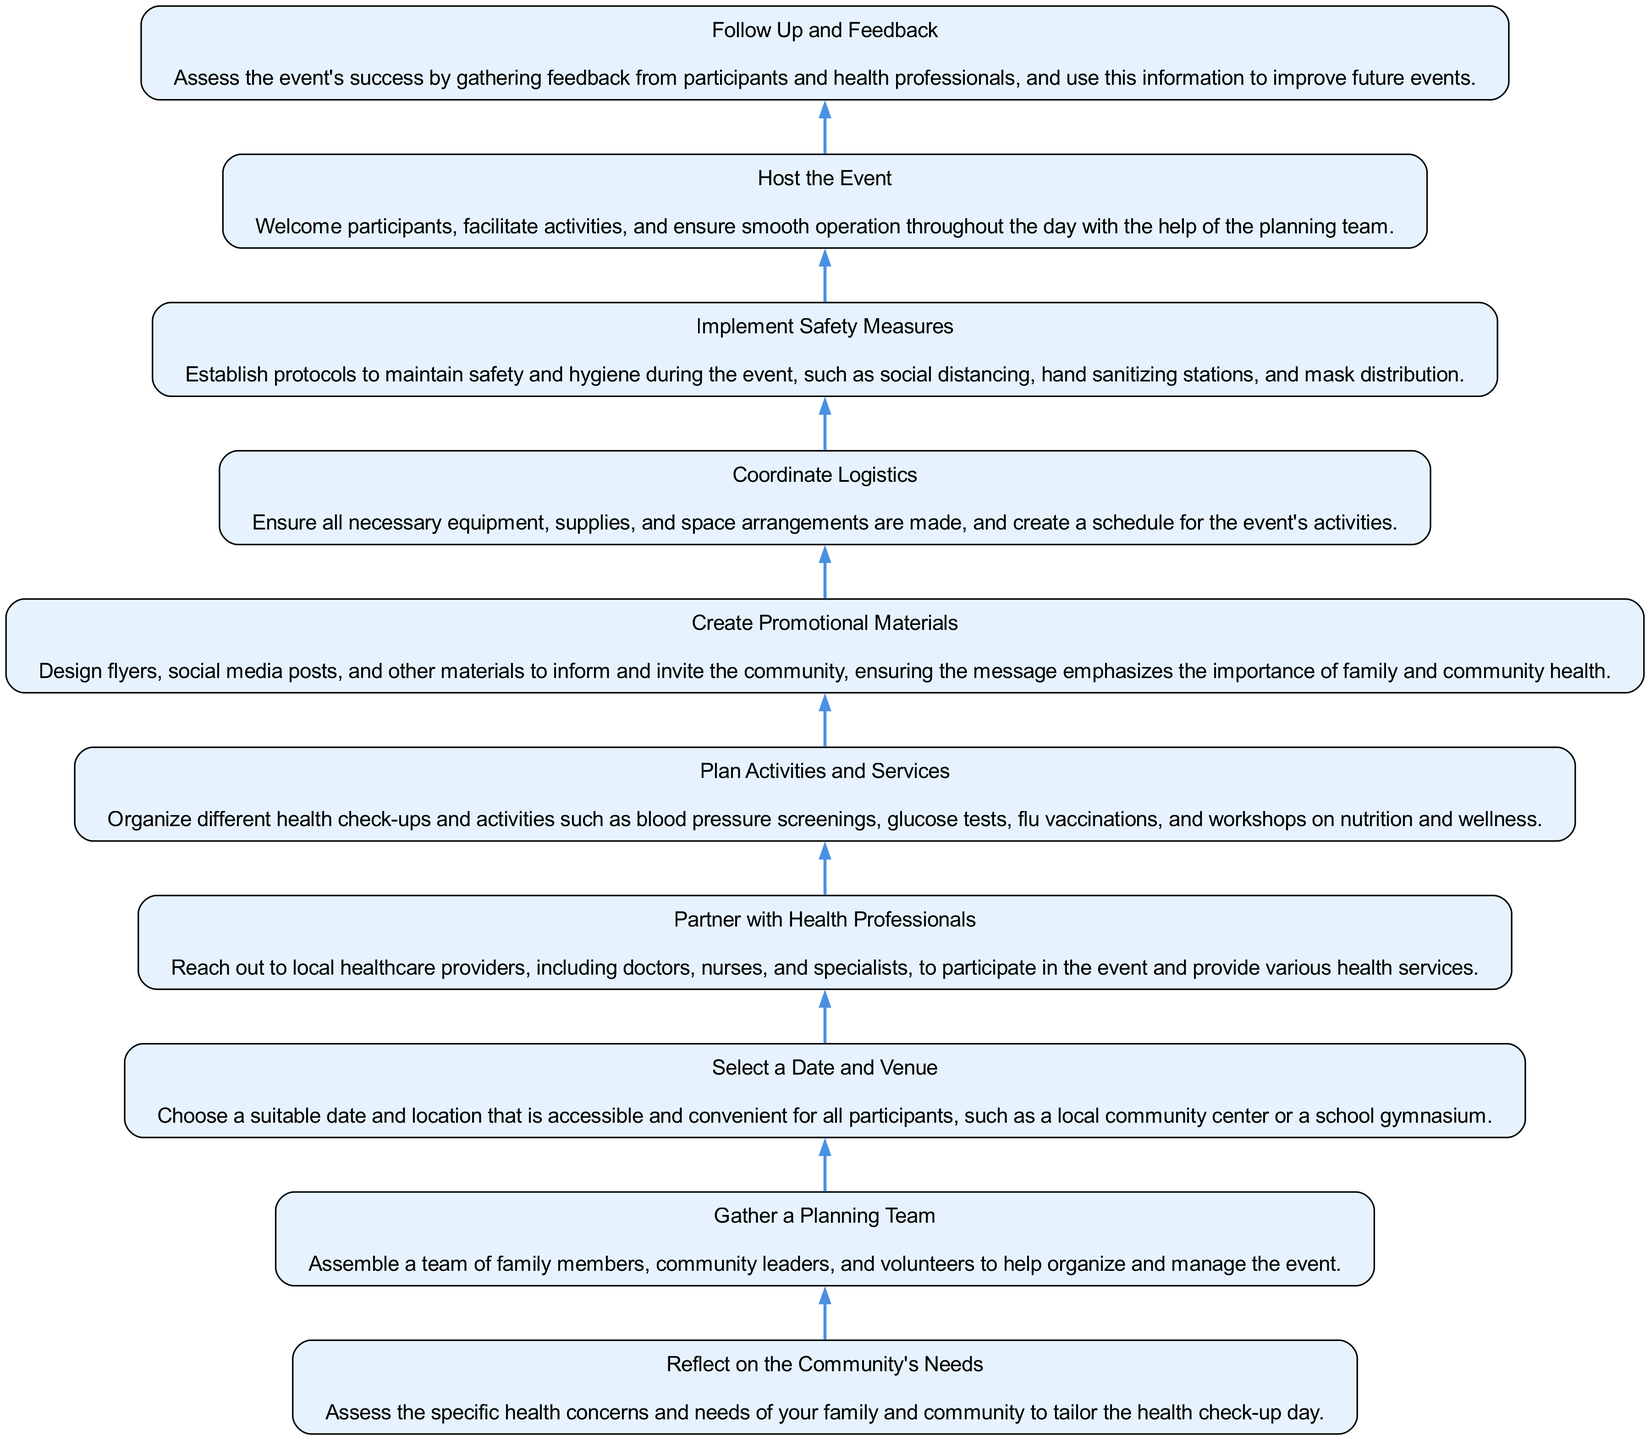What is the first step in the process? The first step in the process is located at the bottom of the flow chart and indicates the need to reflect on the community's health concerns.
Answer: Reflect on the Community's Needs How many activities are planned according to the diagram? The diagram does not specify a number of activities, but it outlines a node that mentions organizing different health check-ups and activities.
Answer: Plan Activities and Services What is the last step in the sequence? The last step is found at the top of the diagram, indicating the need to follow up and gather feedback regarding the event.
Answer: Follow Up and Feedback Which node indicates the importance of health professionals? The node that discusses partnerships with local healthcare providers highlights their importance.
Answer: Partner with Health Professionals What shape do the nodes in this diagram have? Each node in the diagram is shaped like a rectangle, which is specified in the characteristics of the nodes mentioned in the code.
Answer: Rectangle How does the flow of actions progress in this diagram? The flow progresses from bottom to top, indicating sequential actions that build upon each other to culminate in the event's success.
Answer: Bottom to top What is required for the event to be smoothly operated? The smooth operation of the event is ensured through effective coordination, logistics, and the support of the planning team.
Answer: Host the Event What does the diagram emphasize about community health? The diagram emphasizes the importance of family and community health by including this message in its promotional materials.
Answer: Create Promotional Materials What are two key aspects to implement before hosting the event? Before hosting the event, it is crucial to implement safety measures and coordinate logistics to ensure everything is ready and safe.
Answer: Implement Safety Measures and Coordinate Logistics 